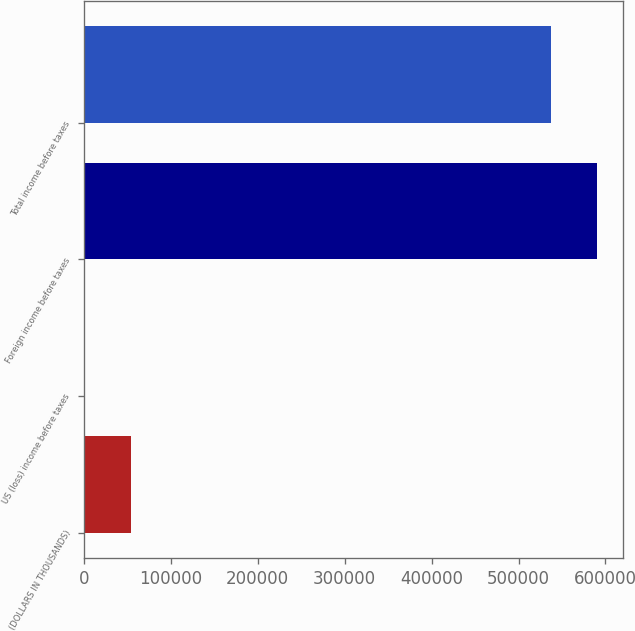Convert chart to OTSL. <chart><loc_0><loc_0><loc_500><loc_500><bar_chart><fcel>(DOLLARS IN THOUSANDS)<fcel>US (loss) income before taxes<fcel>Foreign income before taxes<fcel>Total income before taxes<nl><fcel>53728.5<fcel>24<fcel>590750<fcel>537045<nl></chart> 